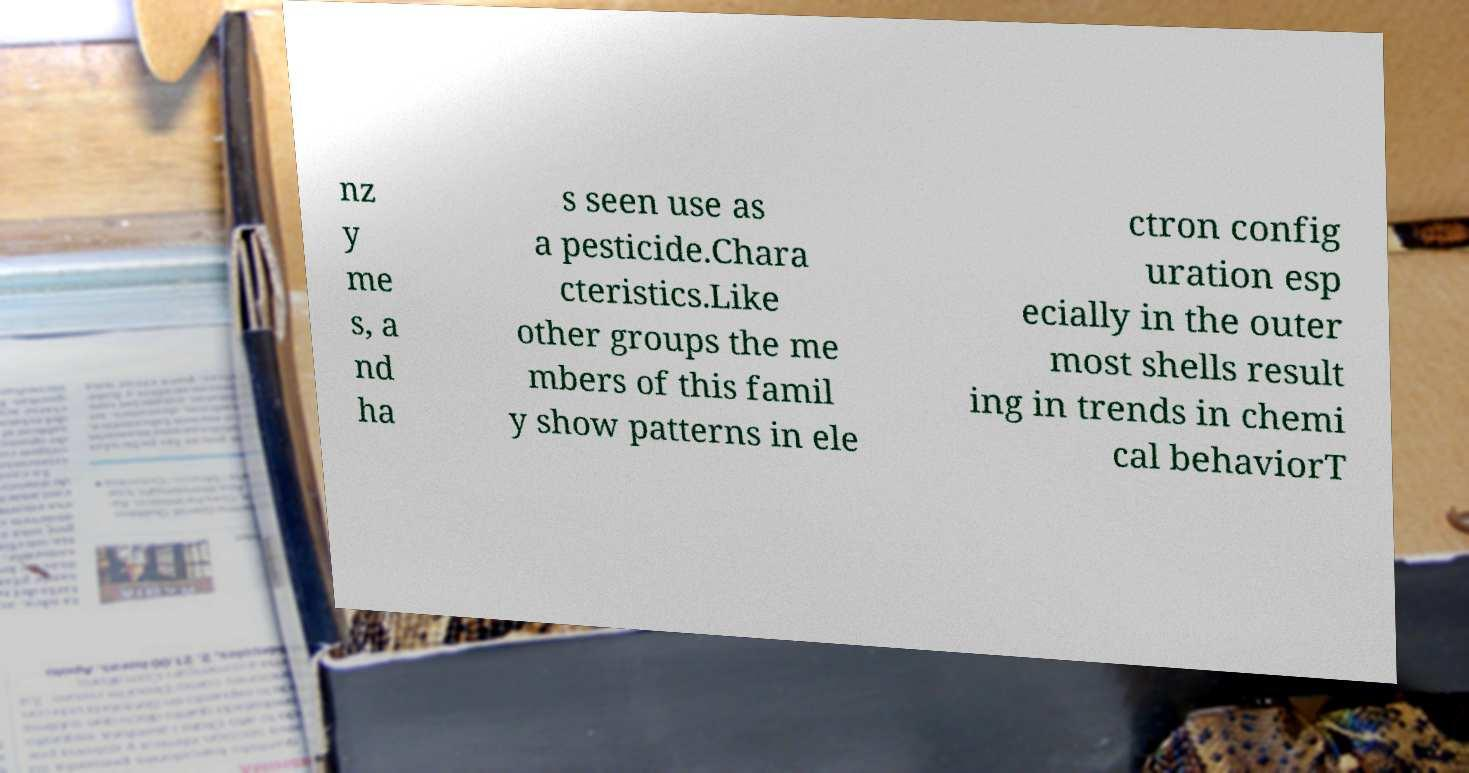Could you extract and type out the text from this image? nz y me s, a nd ha s seen use as a pesticide.Chara cteristics.Like other groups the me mbers of this famil y show patterns in ele ctron config uration esp ecially in the outer most shells result ing in trends in chemi cal behaviorT 